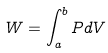<formula> <loc_0><loc_0><loc_500><loc_500>W = \int _ { a } ^ { b } P d V</formula> 